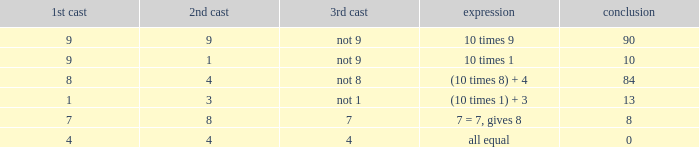What is the result when the 3rd throw is not 8? 84.0. Can you give me this table as a dict? {'header': ['1st cast', '2nd cast', '3rd cast', 'expression', 'conclusion'], 'rows': [['9', '9', 'not 9', '10 times 9', '90'], ['9', '1', 'not 9', '10 times 1', '10'], ['8', '4', 'not 8', '(10 times 8) + 4', '84'], ['1', '3', 'not 1', '(10 times 1) + 3', '13'], ['7', '8', '7', '7 = 7, gives 8', '8'], ['4', '4', '4', 'all equal', '0']]} 